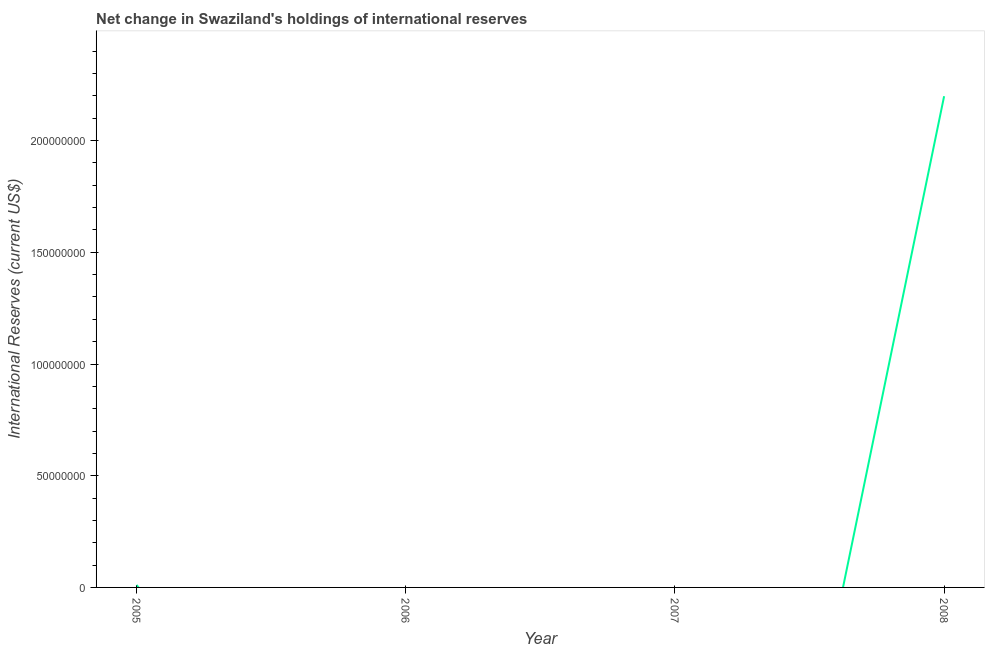What is the reserves and related items in 2007?
Give a very brief answer. 0. Across all years, what is the maximum reserves and related items?
Ensure brevity in your answer.  2.20e+08. Across all years, what is the minimum reserves and related items?
Make the answer very short. 0. In which year was the reserves and related items maximum?
Your answer should be very brief. 2008. What is the sum of the reserves and related items?
Give a very brief answer. 2.21e+08. What is the difference between the reserves and related items in 2005 and 2008?
Your response must be concise. -2.19e+08. What is the average reserves and related items per year?
Your answer should be very brief. 5.52e+07. What is the median reserves and related items?
Ensure brevity in your answer.  5.52e+05. What is the ratio of the reserves and related items in 2005 to that in 2008?
Provide a short and direct response. 0.01. What is the difference between the highest and the lowest reserves and related items?
Provide a short and direct response. 2.20e+08. What is the difference between two consecutive major ticks on the Y-axis?
Keep it short and to the point. 5.00e+07. Does the graph contain any zero values?
Make the answer very short. Yes. Does the graph contain grids?
Your answer should be very brief. No. What is the title of the graph?
Your answer should be very brief. Net change in Swaziland's holdings of international reserves. What is the label or title of the X-axis?
Your answer should be compact. Year. What is the label or title of the Y-axis?
Your answer should be very brief. International Reserves (current US$). What is the International Reserves (current US$) in 2005?
Offer a very short reply. 1.10e+06. What is the International Reserves (current US$) in 2008?
Offer a very short reply. 2.20e+08. What is the difference between the International Reserves (current US$) in 2005 and 2008?
Give a very brief answer. -2.19e+08. What is the ratio of the International Reserves (current US$) in 2005 to that in 2008?
Your response must be concise. 0.01. 